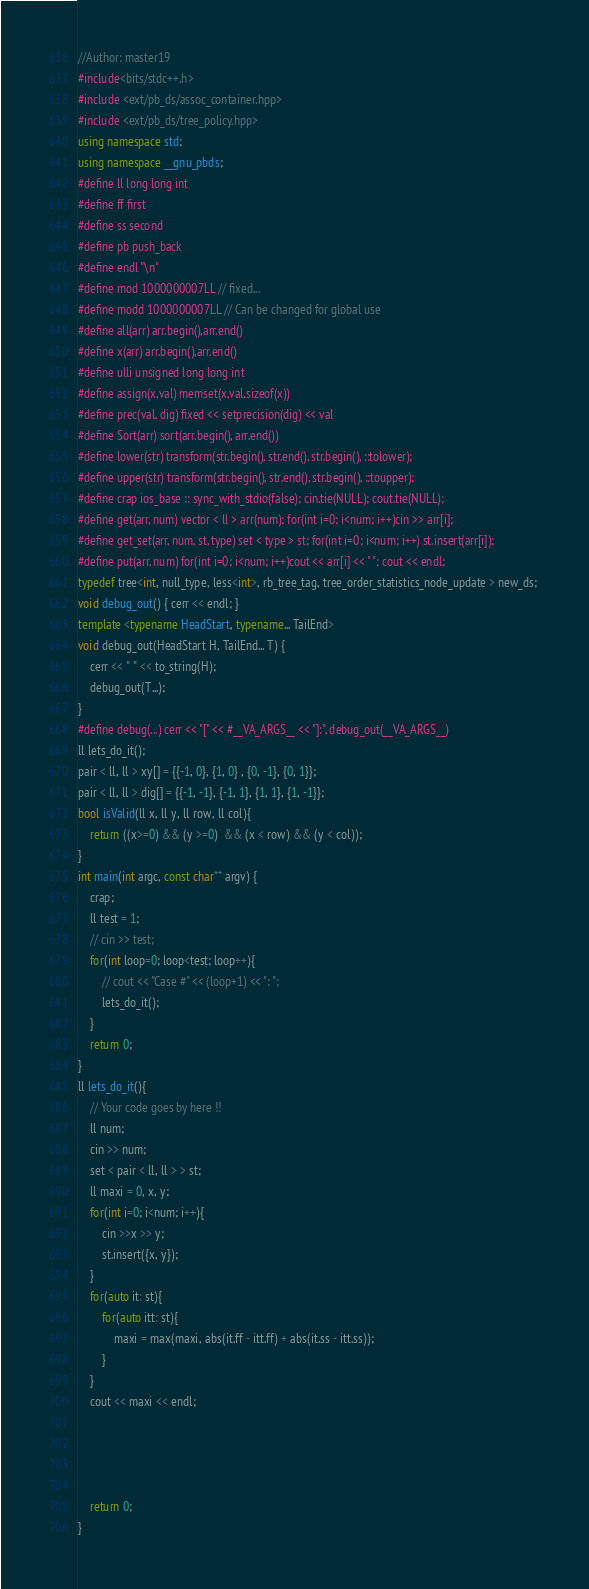<code> <loc_0><loc_0><loc_500><loc_500><_C++_>//Author: master19
#include<bits/stdc++.h>
#include <ext/pb_ds/assoc_container.hpp>
#include <ext/pb_ds/tree_policy.hpp>
using namespace std;
using namespace __gnu_pbds;
#define ll long long int
#define ff first 
#define ss second 
#define pb push_back
#define endl "\n"
#define mod 1000000007LL // fixed...
#define modd 1000000007LL // Can be changed for global use
#define all(arr) arr.begin(),arr.end()
#define x(arr) arr.begin(),arr.end()
#define ulli unsigned long long int
#define assign(x,val) memset(x,val,sizeof(x))
#define prec(val, dig) fixed << setprecision(dig) << val
#define Sort(arr) sort(arr.begin(), arr.end())
#define lower(str) transform(str.begin(), str.end(), str.begin(), ::tolower);
#define upper(str) transform(str.begin(), str.end(), str.begin(), ::toupper);
#define crap ios_base :: sync_with_stdio(false); cin.tie(NULL); cout.tie(NULL);
#define get(arr, num) vector < ll > arr(num); for(int i=0; i<num; i++)cin >> arr[i];
#define get_set(arr, num, st, type) set < type > st; for(int i=0; i<num; i++) st.insert(arr[i]);
#define put(arr, num) for(int i=0; i<num; i++)cout << arr[i] << " "; cout << endl;
typedef tree<int, null_type, less<int>, rb_tree_tag, tree_order_statistics_node_update > new_ds; 
void debug_out() { cerr << endl; }
template <typename HeadStart, typename... TailEnd>
void debug_out(HeadStart H, TailEnd... T) {
    cerr << " " << to_string(H);
    debug_out(T...);
}
#define debug(...) cerr << "[" << #__VA_ARGS__ << "]:", debug_out(__VA_ARGS__)
ll lets_do_it();
pair < ll, ll > xy[] = {{-1, 0}, {1, 0} , {0, -1}, {0, 1}};
pair < ll, ll > dig[] = {{-1, -1}, {-1, 1}, {1, 1}, {1, -1}};
bool isValid(ll x, ll y, ll row, ll col){
    return ((x>=0) && (y >=0)  && (x < row) && (y < col));
}
int main(int argc, const char** argv) {
    crap;
    ll test = 1;
    // cin >> test;
    for(int loop=0; loop<test; loop++){
        // cout << "Case #" << (loop+1) << ": "; 
        lets_do_it();
    }
    return 0;
}
ll lets_do_it(){
    // Your code goes by here !!
    ll num;
    cin >> num;
    set < pair < ll, ll > > st;
    ll maxi = 0, x, y;
    for(int i=0; i<num; i++){
        cin >>x >> y;
        st.insert({x, y});
    }
    for(auto it: st){
        for(auto itt: st){
            maxi = max(maxi, abs(it.ff - itt.ff) + abs(it.ss - itt.ss));
        }
    }
    cout << maxi << endl;




    return 0;
}
</code> 